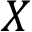<formula> <loc_0><loc_0><loc_500><loc_500>X</formula> 